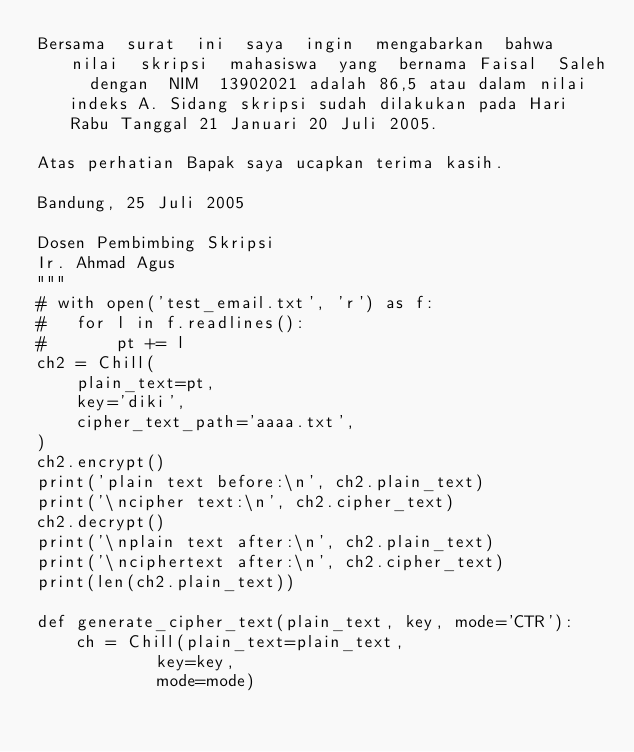Convert code to text. <code><loc_0><loc_0><loc_500><loc_500><_Python_>Bersama  surat  ini  saya  ingin  mengabarkan  bahwa  nilai  skripsi  mahasiswa  yang  bernama Faisal  Saleh  dengan  NIM  13902021 adalah 86,5 atau dalam nilai indeks A. Sidang skripsi sudah dilakukan pada Hari Rabu Tanggal 21 Januari 20 Juli 2005.

Atas perhatian Bapak saya ucapkan terima kasih.

Bandung, 25 Juli 2005

Dosen Pembimbing Skripsi
Ir. Ahmad Agus
"""
# with open('test_email.txt', 'r') as f:
# 	for l in f.readlines():
# 		pt += l
ch2 = Chill(
	plain_text=pt,
	key='diki',
	cipher_text_path='aaaa.txt',
)
ch2.encrypt()
print('plain text before:\n', ch2.plain_text)
print('\ncipher text:\n', ch2.cipher_text)
ch2.decrypt()
print('\nplain text after:\n', ch2.plain_text)
print('\nciphertext after:\n', ch2.cipher_text)
print(len(ch2.plain_text))

def generate_cipher_text(plain_text, key, mode='CTR'):
	ch = Chill(plain_text=plain_text,
			key=key,
			mode=mode)
	
	
	</code> 